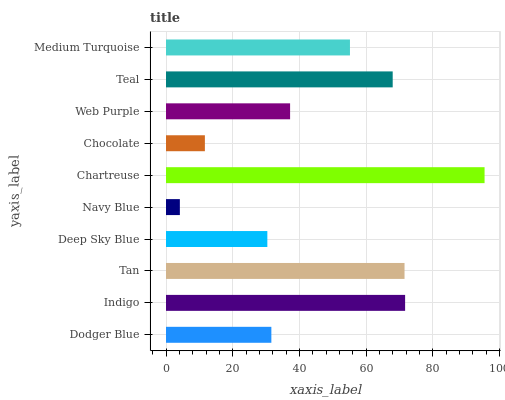Is Navy Blue the minimum?
Answer yes or no. Yes. Is Chartreuse the maximum?
Answer yes or no. Yes. Is Indigo the minimum?
Answer yes or no. No. Is Indigo the maximum?
Answer yes or no. No. Is Indigo greater than Dodger Blue?
Answer yes or no. Yes. Is Dodger Blue less than Indigo?
Answer yes or no. Yes. Is Dodger Blue greater than Indigo?
Answer yes or no. No. Is Indigo less than Dodger Blue?
Answer yes or no. No. Is Medium Turquoise the high median?
Answer yes or no. Yes. Is Web Purple the low median?
Answer yes or no. Yes. Is Teal the high median?
Answer yes or no. No. Is Medium Turquoise the low median?
Answer yes or no. No. 